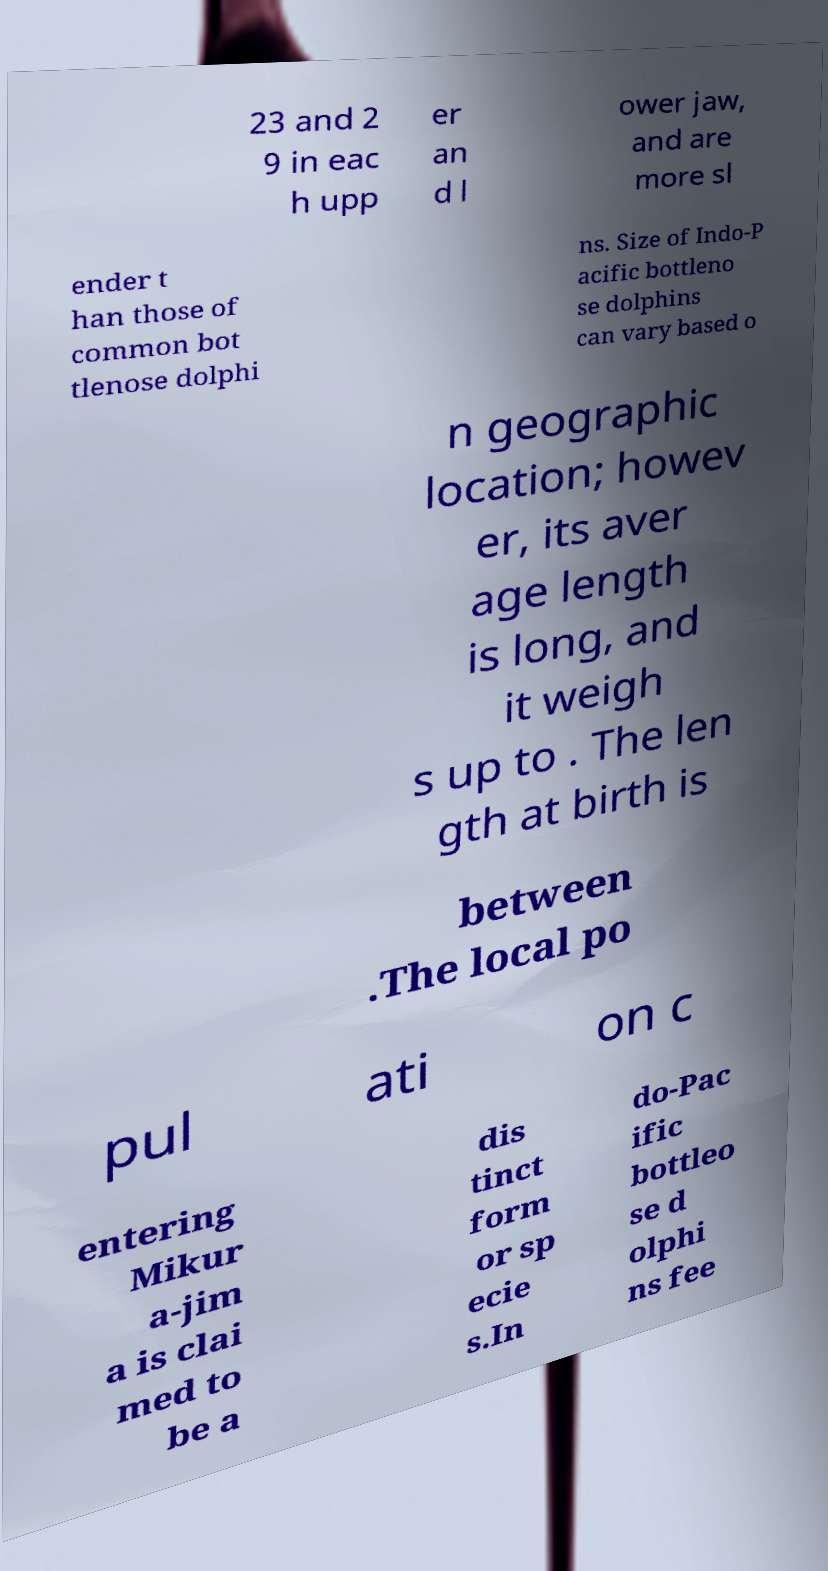Please read and relay the text visible in this image. What does it say? 23 and 2 9 in eac h upp er an d l ower jaw, and are more sl ender t han those of common bot tlenose dolphi ns. Size of Indo-P acific bottleno se dolphins can vary based o n geographic location; howev er, its aver age length is long, and it weigh s up to . The len gth at birth is between .The local po pul ati on c entering Mikur a-jim a is clai med to be a dis tinct form or sp ecie s.In do-Pac ific bottleo se d olphi ns fee 